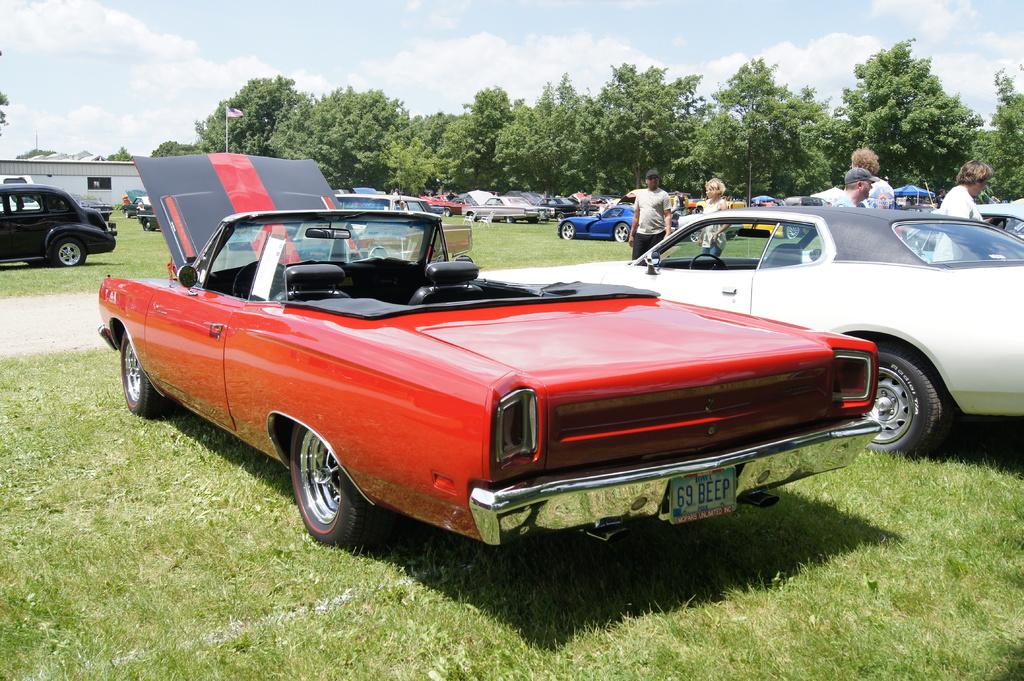What types of vehicles are parked on the ground in the image? There are motor vehicles parked on the ground in the image. What else can be seen on the ground in the image? There are persons standing on the ground in the image. What structures are visible in the image? There are buildings in the image. What is the flag attached to in the image? The flag is attached to a flag post in the image. What type of vegetation is present in the image? There are trees in the image. What is visible in the sky in the image? The sky is visible in the image, and clouds are present in the sky. What type of cloth is draped over the coach in the image? There is no coach or cloth present in the image. What is the rod used for in the image? There is no rod present in the image. 